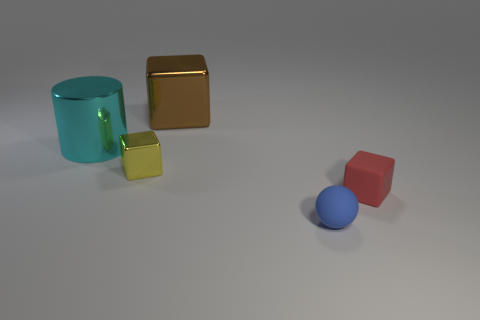Add 5 big gray metal cylinders. How many objects exist? 10 Subtract all brown balls. Subtract all red cylinders. How many balls are left? 1 Subtract all spheres. How many objects are left? 4 Subtract all big metallic cubes. Subtract all big cyan objects. How many objects are left? 3 Add 5 small matte things. How many small matte things are left? 7 Add 4 big metallic blocks. How many big metallic blocks exist? 5 Subtract 1 cyan cylinders. How many objects are left? 4 